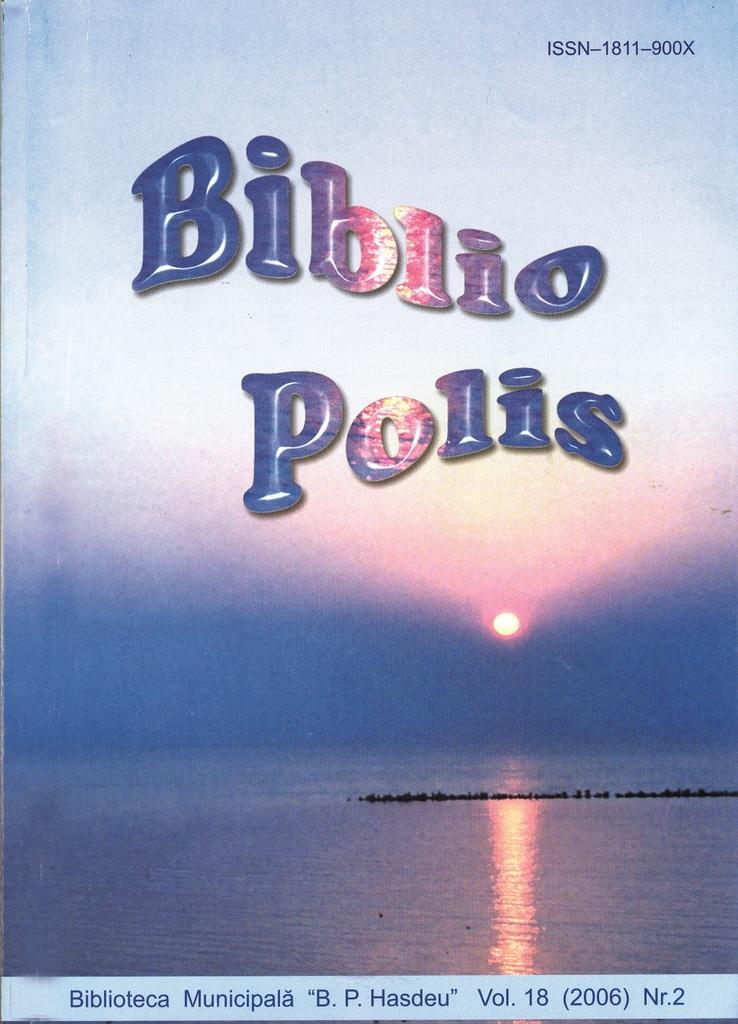The wallpaper is biblio polis?
Your answer should be compact. Yes. What year is at the bottom?
Ensure brevity in your answer.  2006. 